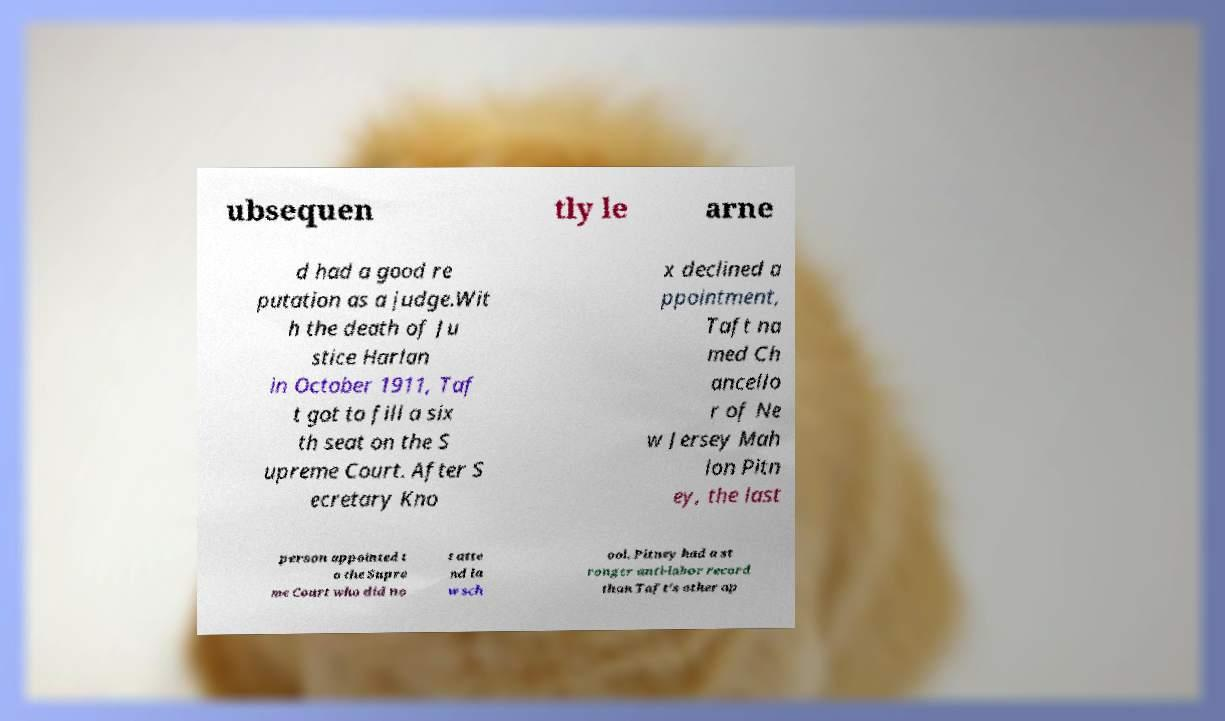I need the written content from this picture converted into text. Can you do that? ubsequen tly le arne d had a good re putation as a judge.Wit h the death of Ju stice Harlan in October 1911, Taf t got to fill a six th seat on the S upreme Court. After S ecretary Kno x declined a ppointment, Taft na med Ch ancello r of Ne w Jersey Mah lon Pitn ey, the last person appointed t o the Supre me Court who did no t atte nd la w sch ool. Pitney had a st ronger anti-labor record than Taft's other ap 